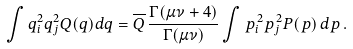<formula> <loc_0><loc_0><loc_500><loc_500>\int q _ { i } ^ { 2 } q _ { j } ^ { 2 } Q ( q ) d q = \overline { Q } \, \frac { \Gamma ( \mu \nu + 4 ) } { \Gamma ( \mu \nu ) } \int p _ { i } ^ { \, 2 } p _ { j } ^ { \, 2 } P ( p ) \, d p \, .</formula> 